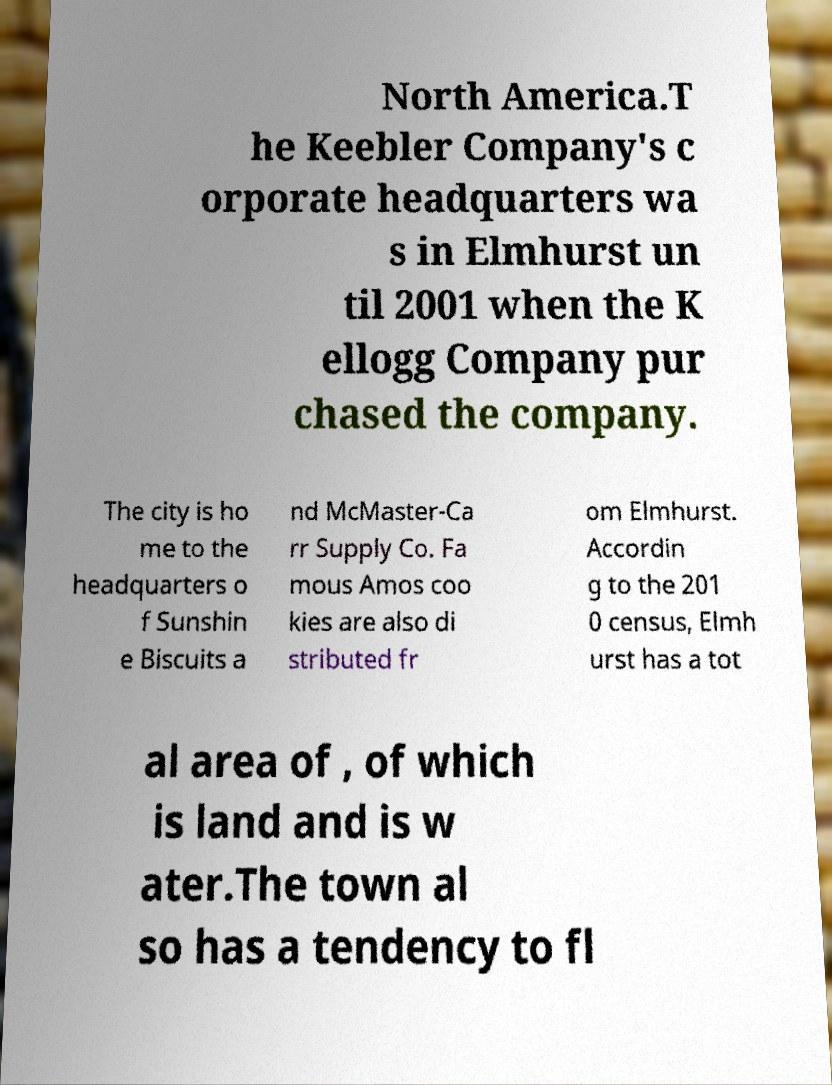Please identify and transcribe the text found in this image. North America.T he Keebler Company's c orporate headquarters wa s in Elmhurst un til 2001 when the K ellogg Company pur chased the company. The city is ho me to the headquarters o f Sunshin e Biscuits a nd McMaster-Ca rr Supply Co. Fa mous Amos coo kies are also di stributed fr om Elmhurst. Accordin g to the 201 0 census, Elmh urst has a tot al area of , of which is land and is w ater.The town al so has a tendency to fl 